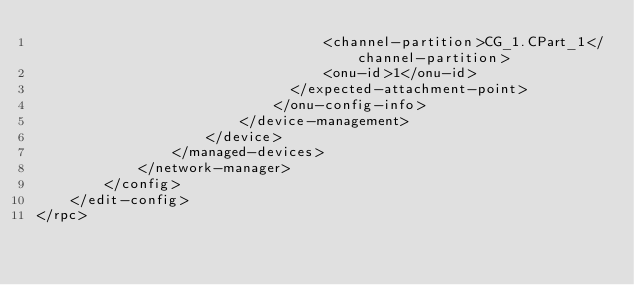<code> <loc_0><loc_0><loc_500><loc_500><_XML_>                                  <channel-partition>CG_1.CPart_1</channel-partition>
                                  <onu-id>1</onu-id>
                              </expected-attachment-point>
                            </onu-config-info>
                        </device-management>
                    </device>
                </managed-devices>
            </network-manager>
        </config>
    </edit-config>
</rpc>
</code> 